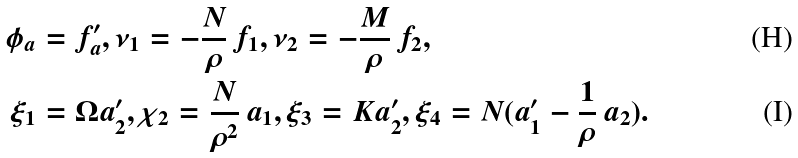Convert formula to latex. <formula><loc_0><loc_0><loc_500><loc_500>\phi _ { a } & = f _ { a } ^ { \prime } , \nu _ { 1 } = - \frac { N } { \rho } \, f _ { 1 } , \nu _ { 2 } = - \frac { M } { \rho } \, f _ { 2 } , \\ \xi _ { 1 } & = \Omega a _ { 2 } ^ { \prime } , \chi _ { 2 } = \frac { N } { \rho ^ { 2 } } \, a _ { 1 } , \xi _ { 3 } = K a _ { 2 } ^ { \prime } , \xi _ { 4 } = N ( a _ { 1 } ^ { \prime } - \frac { 1 } { \rho } \, a _ { 2 } ) .</formula> 